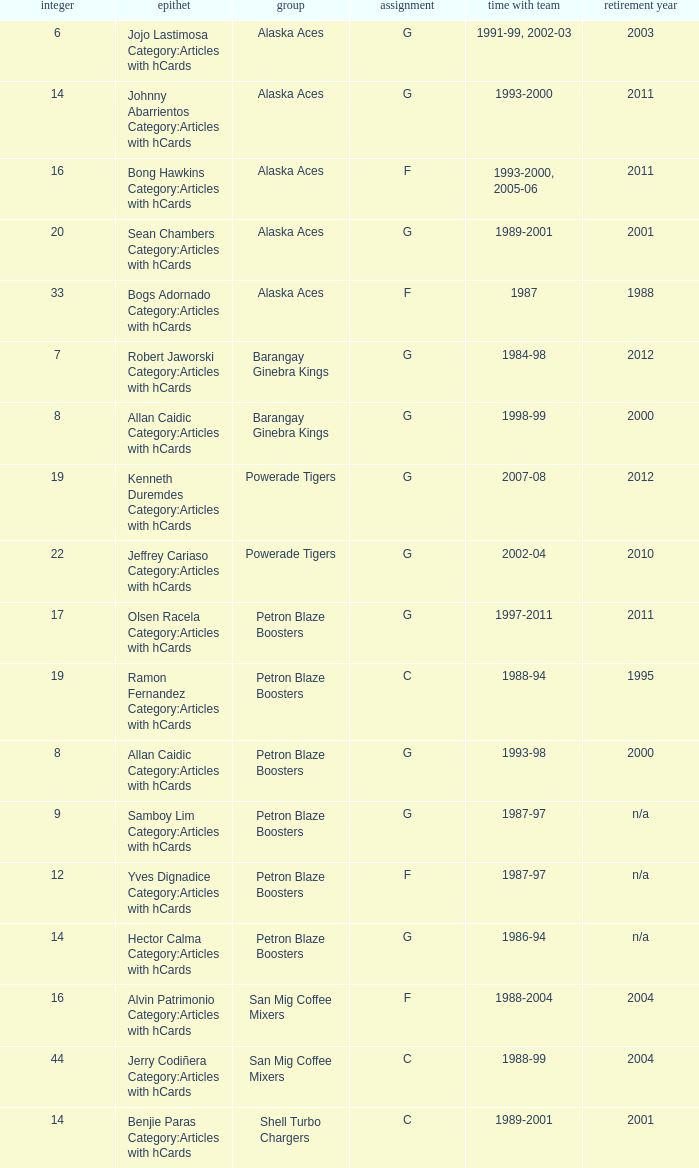Which team is number 14 and had a franchise in 1993-2000? Alaska Aces. 